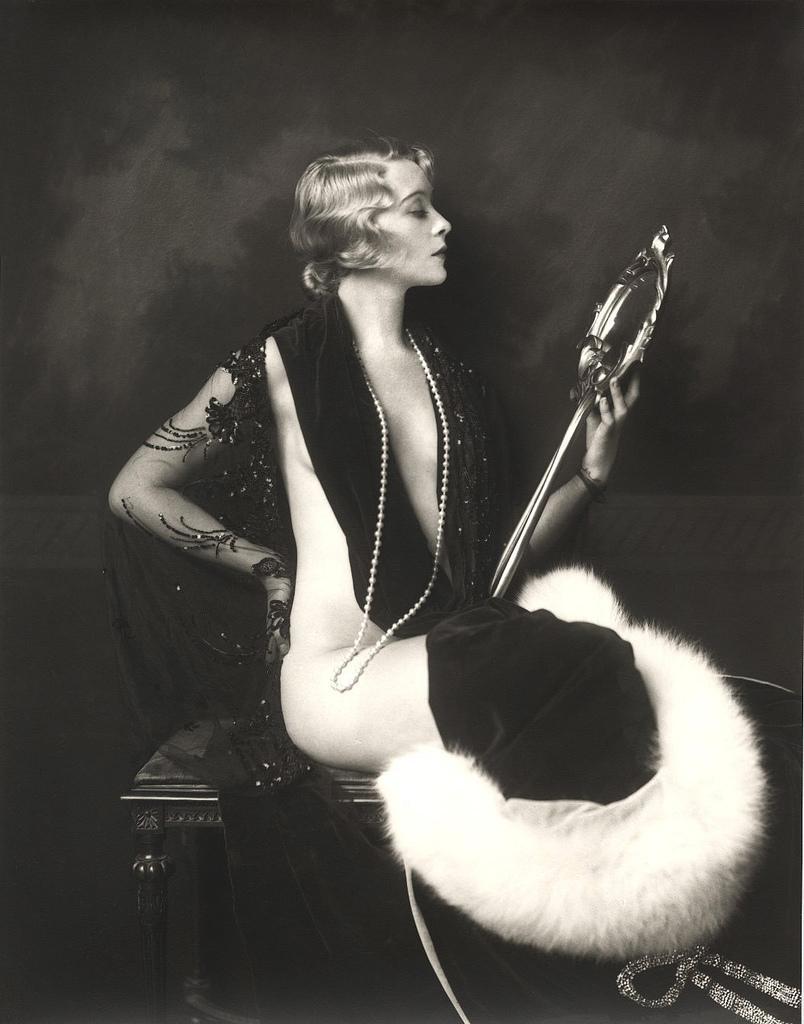Describe this image in one or two sentences. In the middle of the image, there is a woman in a black color dress, holding an object with one hand and sitting on a stool. And the background is dark in color. 